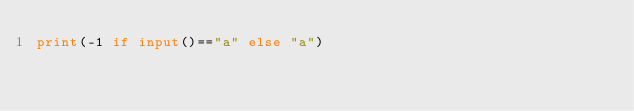<code> <loc_0><loc_0><loc_500><loc_500><_Python_>print(-1 if input()=="a" else "a")</code> 